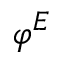<formula> <loc_0><loc_0><loc_500><loc_500>\varphi ^ { E }</formula> 